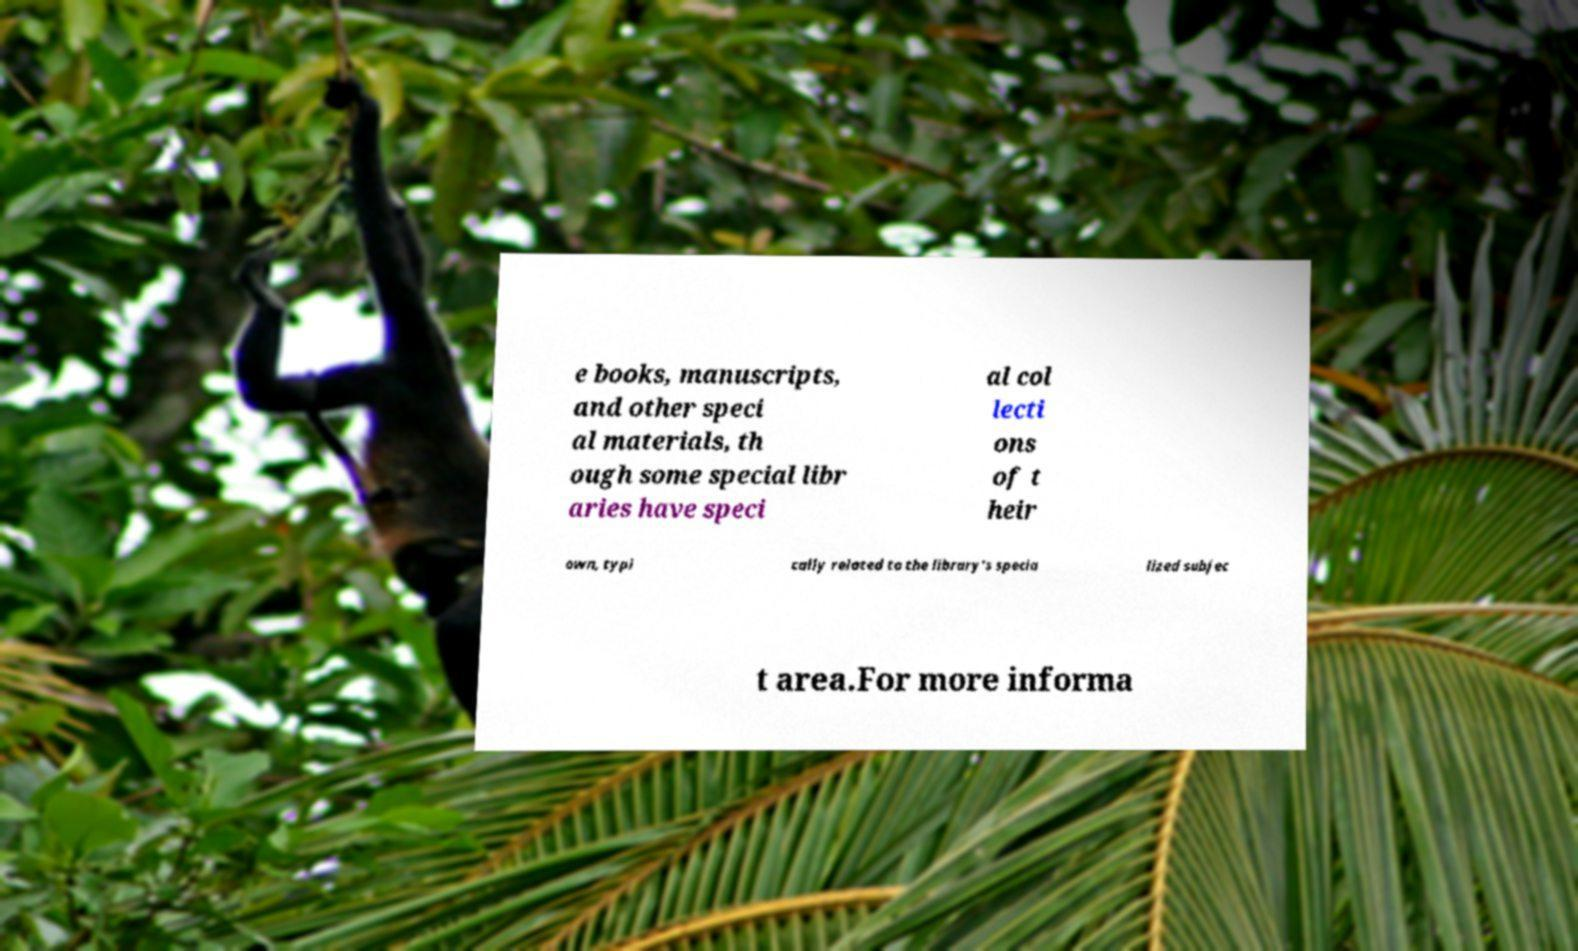For documentation purposes, I need the text within this image transcribed. Could you provide that? e books, manuscripts, and other speci al materials, th ough some special libr aries have speci al col lecti ons of t heir own, typi cally related to the library's specia lized subjec t area.For more informa 